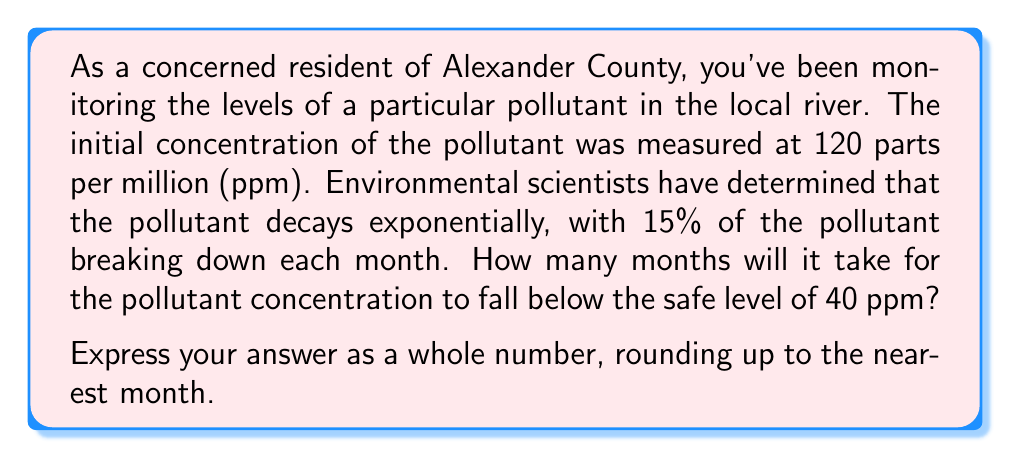Solve this math problem. Let's approach this step-by-step:

1) The initial concentration is 120 ppm, and we want to know when it will fall below 40 ppm.

2) Each month, 85% of the pollutant remains (because 15% decays). We can express this as a decimal: 0.85.

3) We can model this with the exponential decay formula:

   $$ A(t) = A_0 \cdot (1-r)^t $$

   Where:
   $A(t)$ is the amount at time $t$
   $A_0$ is the initial amount
   $r$ is the decay rate per time period
   $t$ is the number of time periods

4) In our case:
   $A_0 = 120$
   $(1-r) = 0.85$
   We want to find $t$ when $A(t) < 40$

5) Let's set up the equation:

   $$ 40 = 120 \cdot (0.85)^t $$

6) Divide both sides by 120:

   $$ \frac{1}{3} = (0.85)^t $$

7) Take the natural log of both sides:

   $$ \ln(\frac{1}{3}) = t \cdot \ln(0.85) $$

8) Solve for $t$:

   $$ t = \frac{\ln(\frac{1}{3})}{\ln(0.85)} \approx 7.22 $$

9) Since we need to round up to the nearest month, our answer is 8 months.
Answer: 8 months 